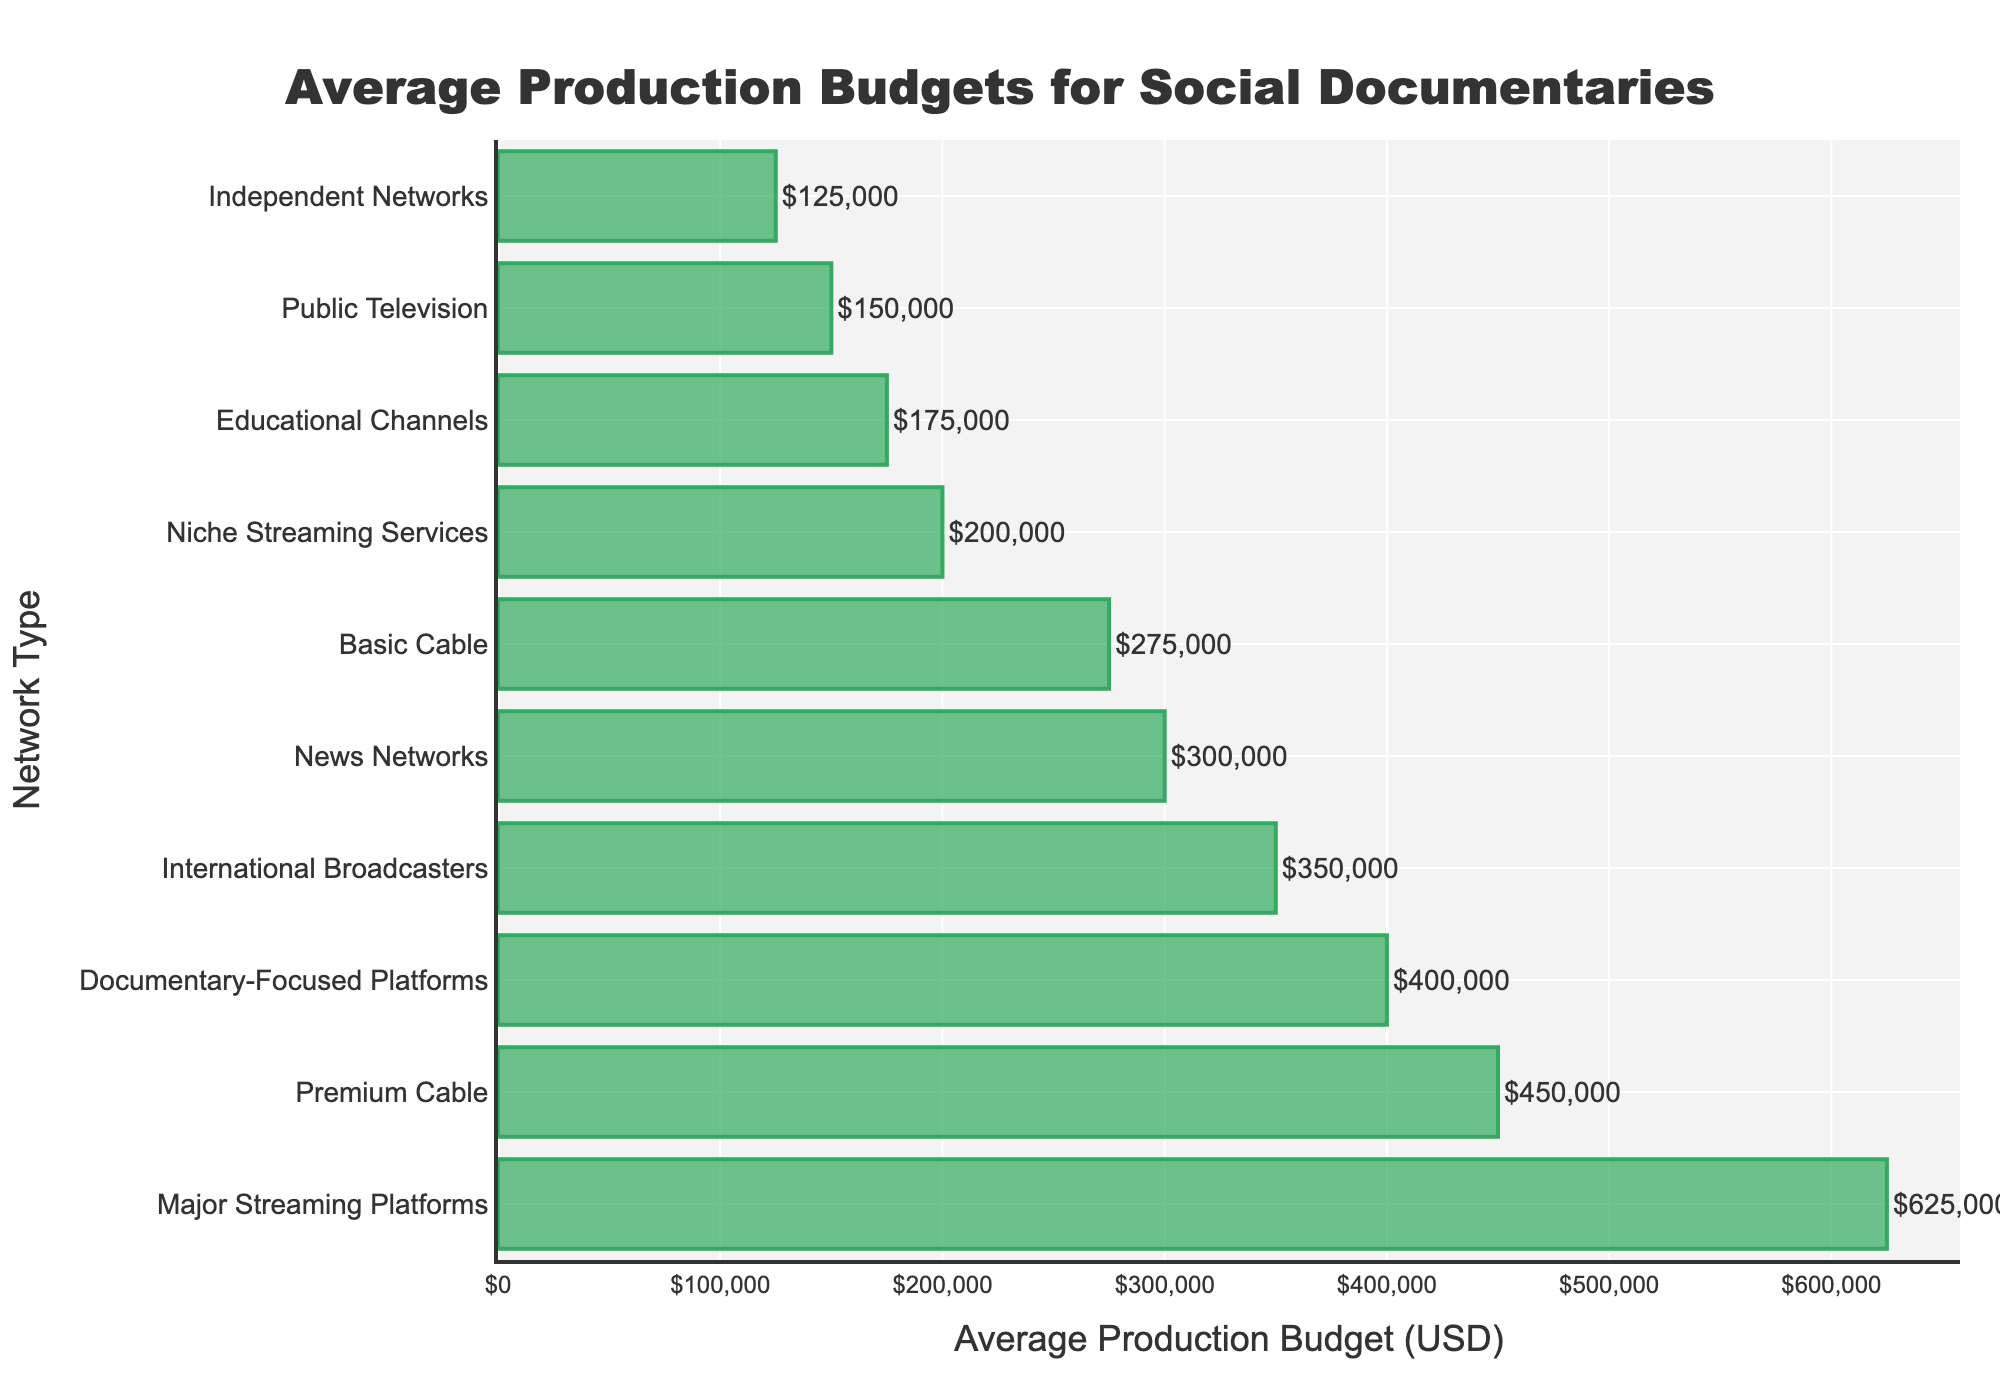What is the average production budget for documentaries on public television? The figure shows that the production budget for Public Television is explicitly labeled.
Answer: $150,000 Which network type has the highest average production budget? The figure sorts average production budgets in descending order. The longest bar at the top corresponds to Major Streaming Platforms.
Answer: Major Streaming Platforms How does the average production budget of Basic Cable compare to Premium Cable? Use the lengths of the bars for Basic Cable and Premium Cable. The bar for Premium Cable is longer, indicating a higher budget.
Answer: Premium Cable has a higher budget What is the difference in average production budget between Independent Networks and Niche Streaming Services? Subtract the value of Independent Networks from Niche Streaming Services. $200,000 - $125,000 = $75,000
Answer: $75,000 Identify two network types that have an average production budget of at least $300,000 but less than $400,000. Look for bars whose values fall within the specified range. News Networks and Documentary-Focused Platforms fit this criterion, with $300,000 and $400,000 respectively.
Answer: News Networks and Documentary-Focused Platforms What is the combined average production budget for Educational Channels and News Networks? Sum the average production budgets for both network types: $175,000 + $300,000 = $475,000
Answer: $475,000 Is the average production budget for International Broadcasters higher or lower than that for Documentary-Focused Platforms? Compare the bars for International Broadcasters and Documentary-Focused Platforms. International Broadcasters has a shorter bar.
Answer: Lower By how much does the average production budget of Major Streaming Platforms exceed that of Public Television? Subtract the values: $625,000 - $150,000 = $475,000
Answer: $475,000 Which network type has the lowest average production budget, and what is it? The shortest bar corresponds to Independent Networks with an average production budget of $125,000.
Answer: Independent Networks, $125,000 